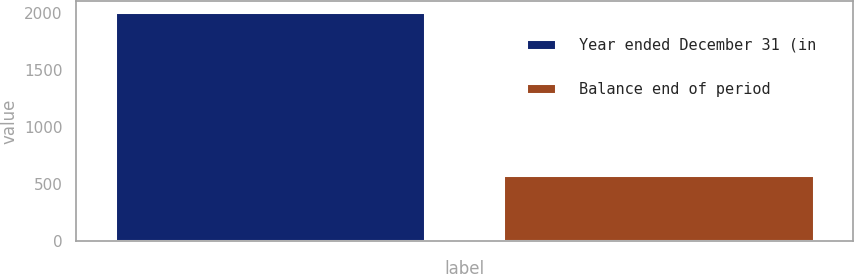Convert chart. <chart><loc_0><loc_0><loc_500><loc_500><bar_chart><fcel>Year ended December 31 (in<fcel>Balance end of period<nl><fcel>2009<fcel>578<nl></chart> 